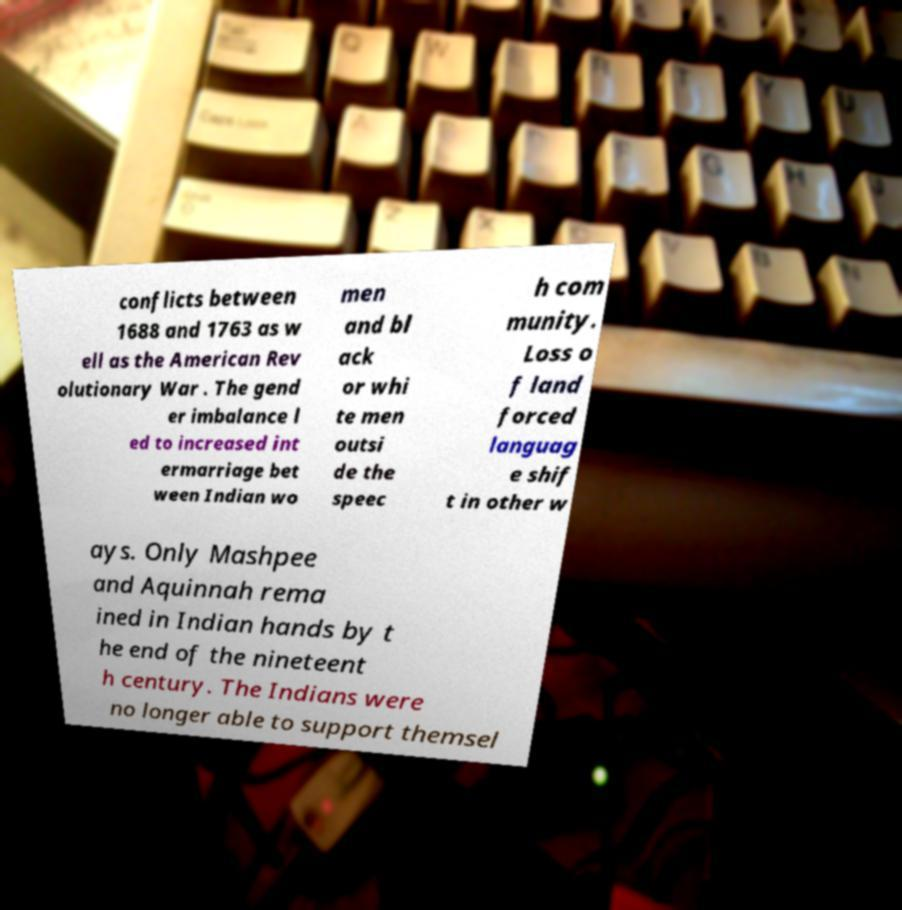Could you extract and type out the text from this image? conflicts between 1688 and 1763 as w ell as the American Rev olutionary War . The gend er imbalance l ed to increased int ermarriage bet ween Indian wo men and bl ack or whi te men outsi de the speec h com munity. Loss o f land forced languag e shif t in other w ays. Only Mashpee and Aquinnah rema ined in Indian hands by t he end of the nineteent h century. The Indians were no longer able to support themsel 